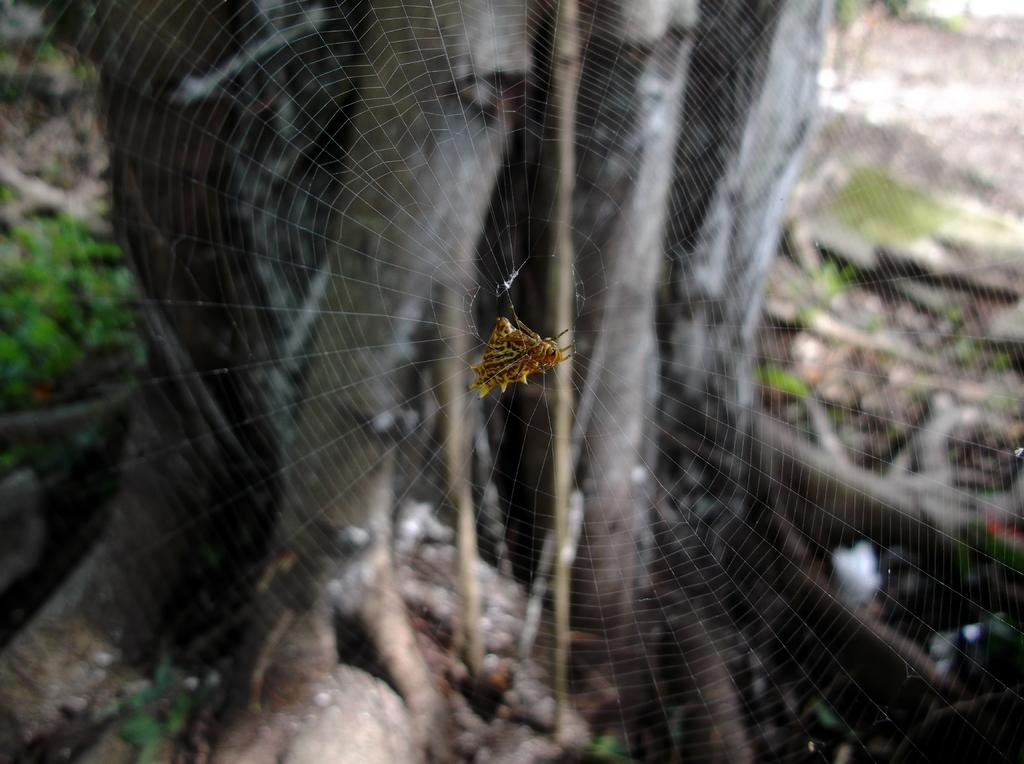What is the main subject of the image? There is a spider in the image. Where is the spider located? The spider is on a spider web. What can be seen in the background of the image? There is a tree and grass in the background of the image. What type of arch can be seen in the background of the image? There is no arch present in the image; it features a spider on a spider web with a tree and grass in the background. 